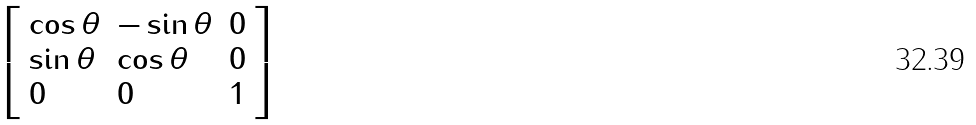Convert formula to latex. <formula><loc_0><loc_0><loc_500><loc_500>\left [ \begin{array} { l l l } { \cos \theta } & { - \sin \theta } & { 0 } \\ { \sin \theta } & { \cos \theta } & { 0 } \\ { 0 } & { 0 } & { 1 } \end{array} \right ]</formula> 